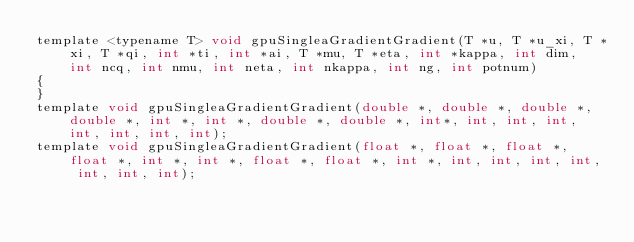<code> <loc_0><loc_0><loc_500><loc_500><_Cuda_>template <typename T> void gpuSingleaGradientGradient(T *u, T *u_xi, T *xi, T *qi, int *ti, int *ai, T *mu, T *eta, int *kappa, int dim, int ncq, int nmu, int neta, int nkappa, int ng, int potnum)
{
}
template void gpuSingleaGradientGradient(double *, double *, double *, double *, int *, int *, double *, double *, int*, int, int, int, int, int, int, int);
template void gpuSingleaGradientGradient(float *, float *, float *, float *, int *, int *, float *, float *, int *, int, int, int, int, int, int, int);
</code> 